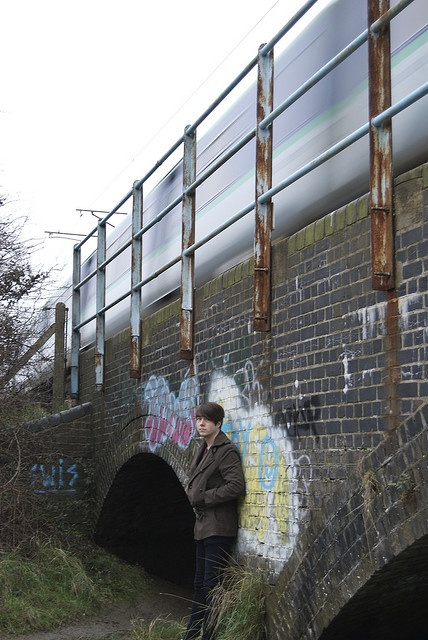Describe the objects in this image and their specific colors. I can see train in white, darkgray, lightgray, and gray tones and people in white, black, and gray tones in this image. 